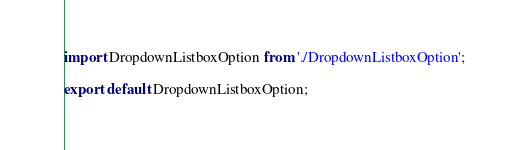Convert code to text. <code><loc_0><loc_0><loc_500><loc_500><_JavaScript_>import DropdownListboxOption from './DropdownListboxOption';

export default DropdownListboxOption;
</code> 